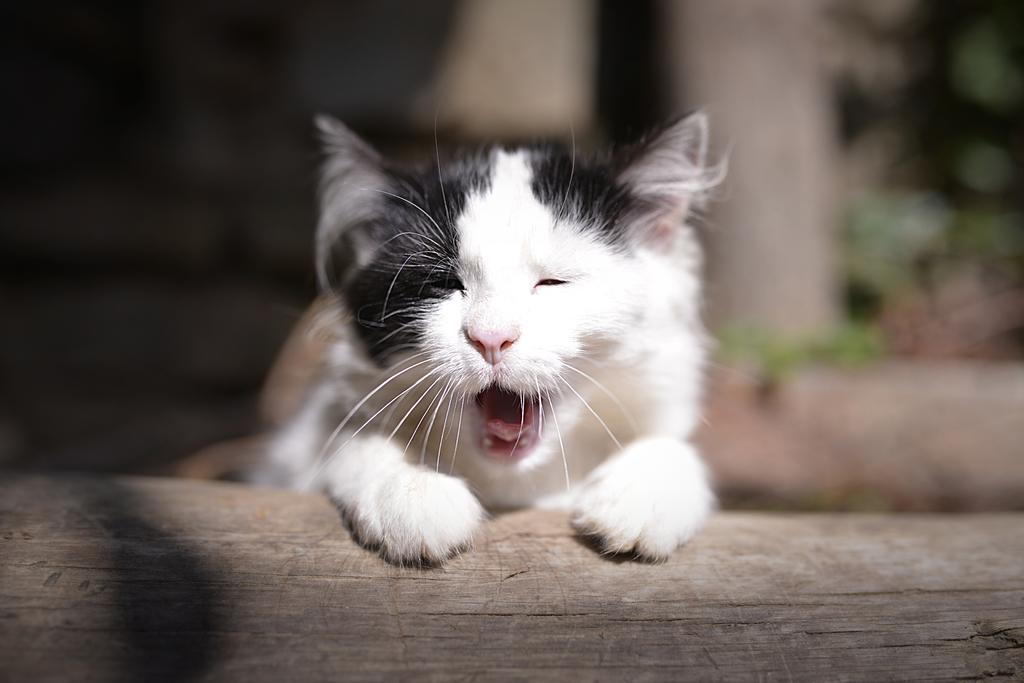What is the main subject in the foreground of the image? There is a cat in the foreground of the image. Can you describe the background of the image? The background of the image is blurry. Are there any specific objects or features visible in the image? There might be a wooden pole at the bottom of the image. What type of crime is being committed in the image? There is no indication of a crime being committed in the image; it features a cat in the foreground and a blurry background. Can you identify any rats in the image? There are no rats present in the image. 